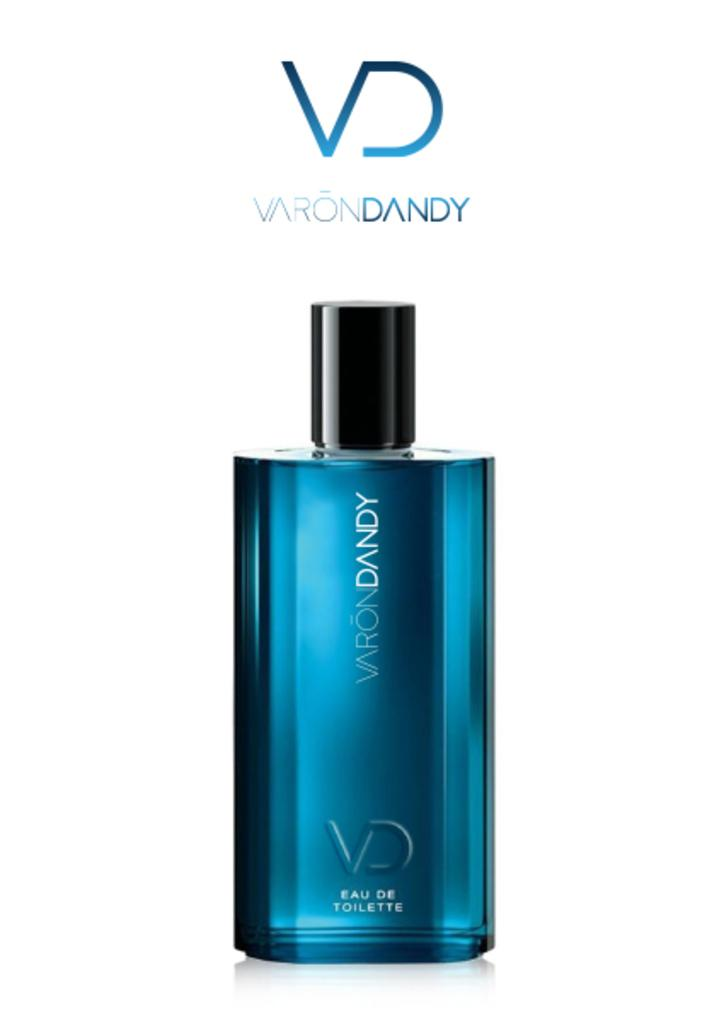<image>
Provide a brief description of the given image. A blue glass bottle of Varon Dandy perfume against a white background. 